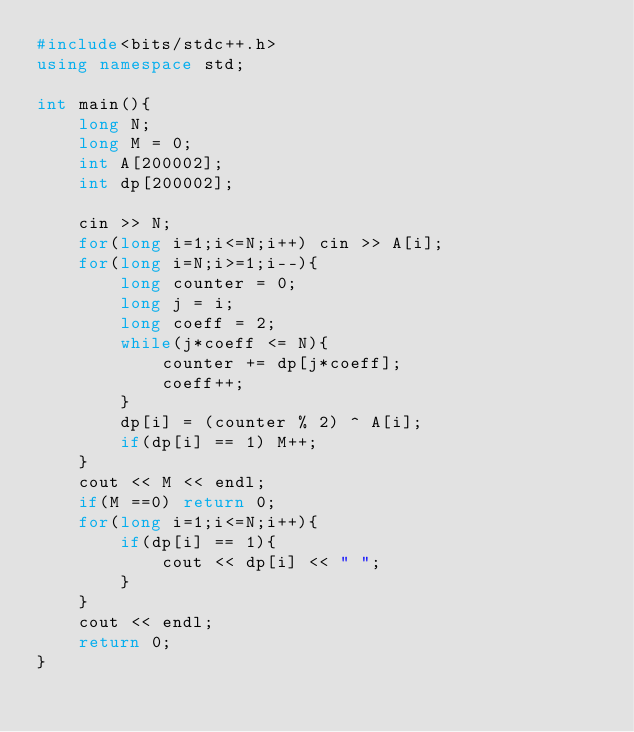<code> <loc_0><loc_0><loc_500><loc_500><_C++_>#include<bits/stdc++.h>
using namespace std;

int main(){
    long N;
    long M = 0;
    int A[200002];
    int dp[200002];

    cin >> N;
    for(long i=1;i<=N;i++) cin >> A[i];
    for(long i=N;i>=1;i--){
        long counter = 0;
        long j = i;
        long coeff = 2;
        while(j*coeff <= N){
            counter += dp[j*coeff];
            coeff++;
        }
        dp[i] = (counter % 2) ^ A[i];
        if(dp[i] == 1) M++;
    }
    cout << M << endl;
    if(M ==0) return 0;
    for(long i=1;i<=N;i++){
        if(dp[i] == 1){
            cout << dp[i] << " ";
        }
    }
    cout << endl;
    return 0;
}</code> 